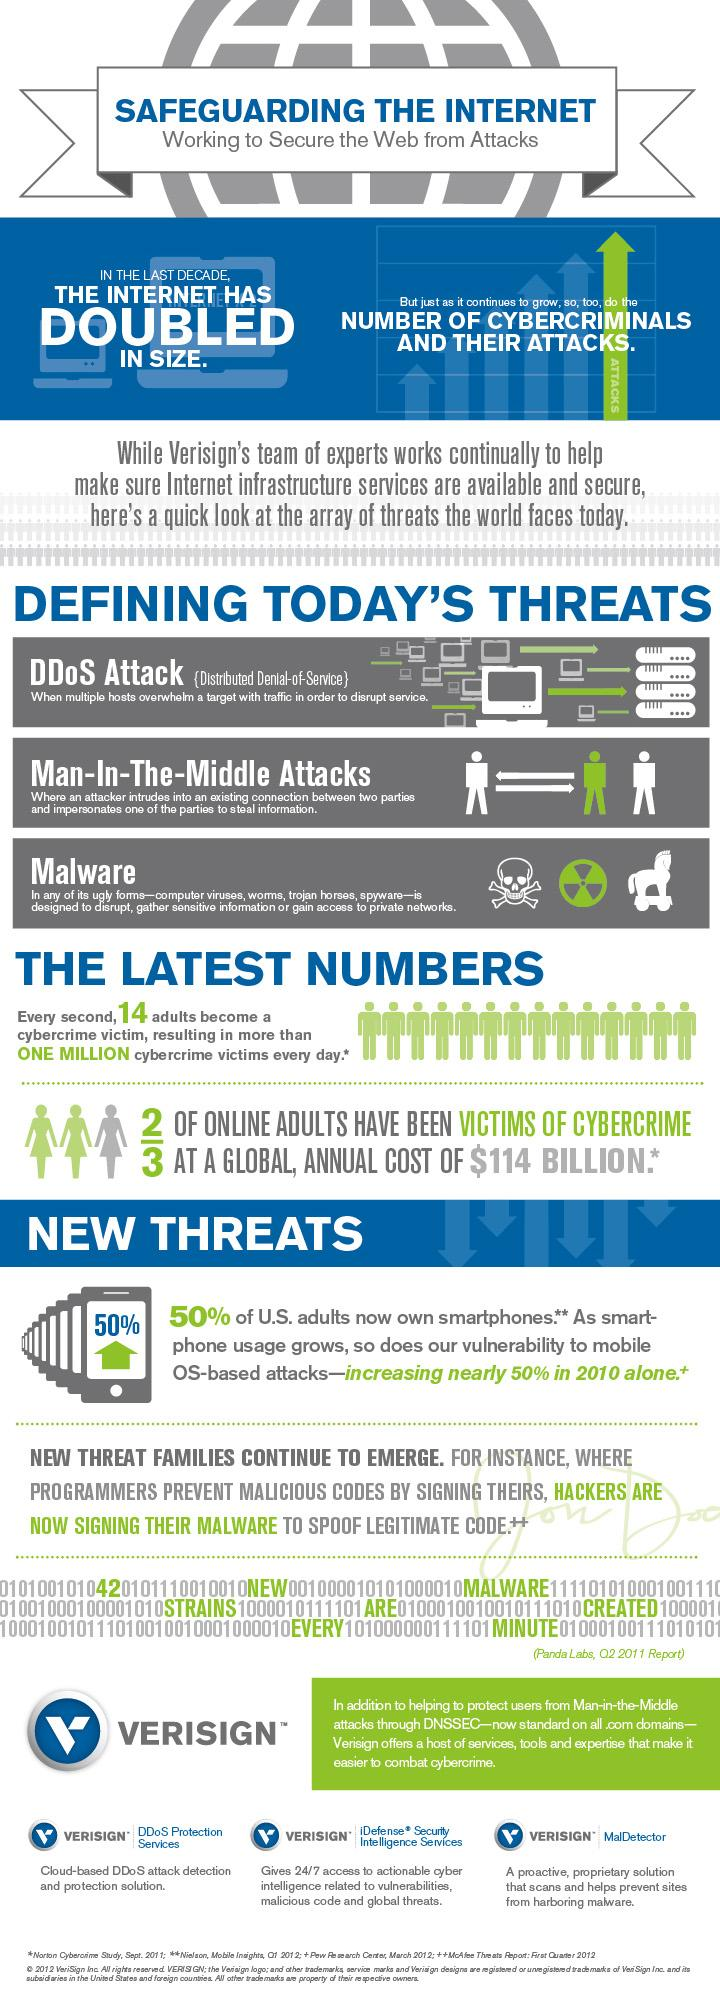Outline some significant characteristics in this image. Out of 3, approximately 1 online adult has not been a victim of cybercrime. 